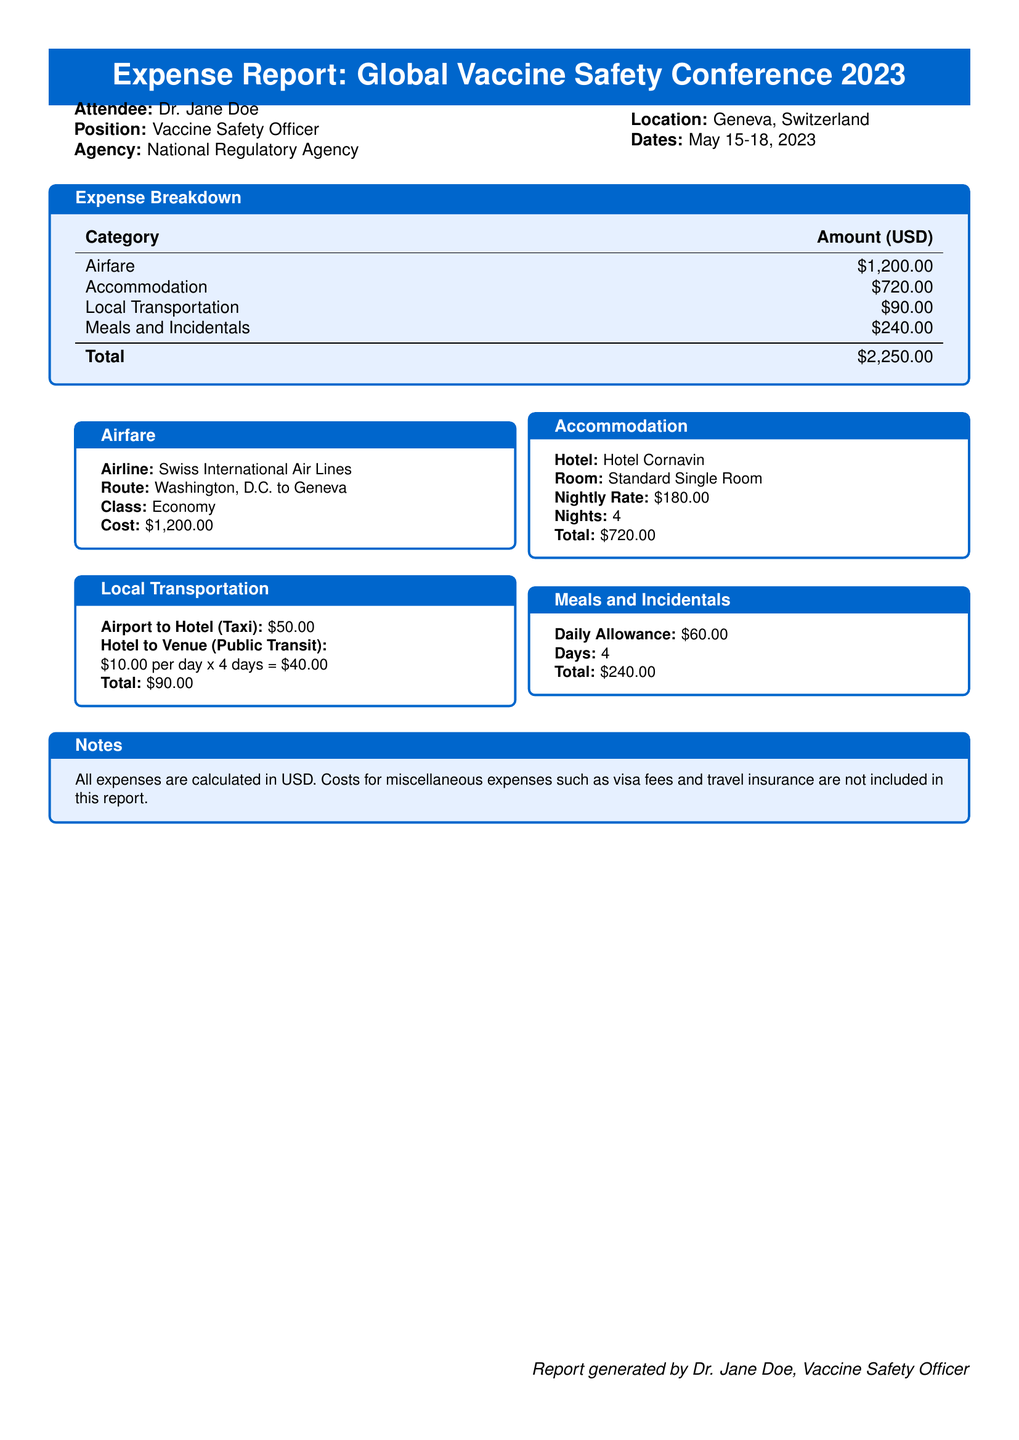What is the total amount of expenses? The total amount of expenses is provided in the breakdown, which sums all categories: Airfare, Accommodation, Local Transportation, and Meals and Incidentals.
Answer: $2,250.00 What is the daily allowance for meals? The daily allowance for meals is specified in the section on Meals and Incidentals.
Answer: $60.00 How many nights did Dr. Jane Doe stay at the hotel? The number of nights stayed is listed in the Accommodation section, which indicates a total of 4 nights.
Answer: 4 What was the cost of the round-trip airfare? The cost of the airfare is mentioned directly in the Airfare section of the document.
Answer: $1,200.00 What type of room did Dr. Jane Doe book? The type of room is stated in the Accommodation section, which specifies a Standard Single Room.
Answer: Standard Single Room What transportation method was used from the hotel to the venue? The local transportation details describe the method used for this route, which involves public transit.
Answer: Public Transit What hotel did Dr. Jane Doe stay in? The name of the hotel is found in the Accommodation section of the document.
Answer: Hotel Cornavin How much was spent on local transportation? The total cost for local transportation is indicated in the breakdown under Local Transportation.
Answer: $90.00 What is the purpose of the trip mentioned in the document? The purpose of the trip is to attend the Global Vaccine Safety Conference, which is highlighted in the title of the expense report.
Answer: Global Vaccine Safety Conference 2023 